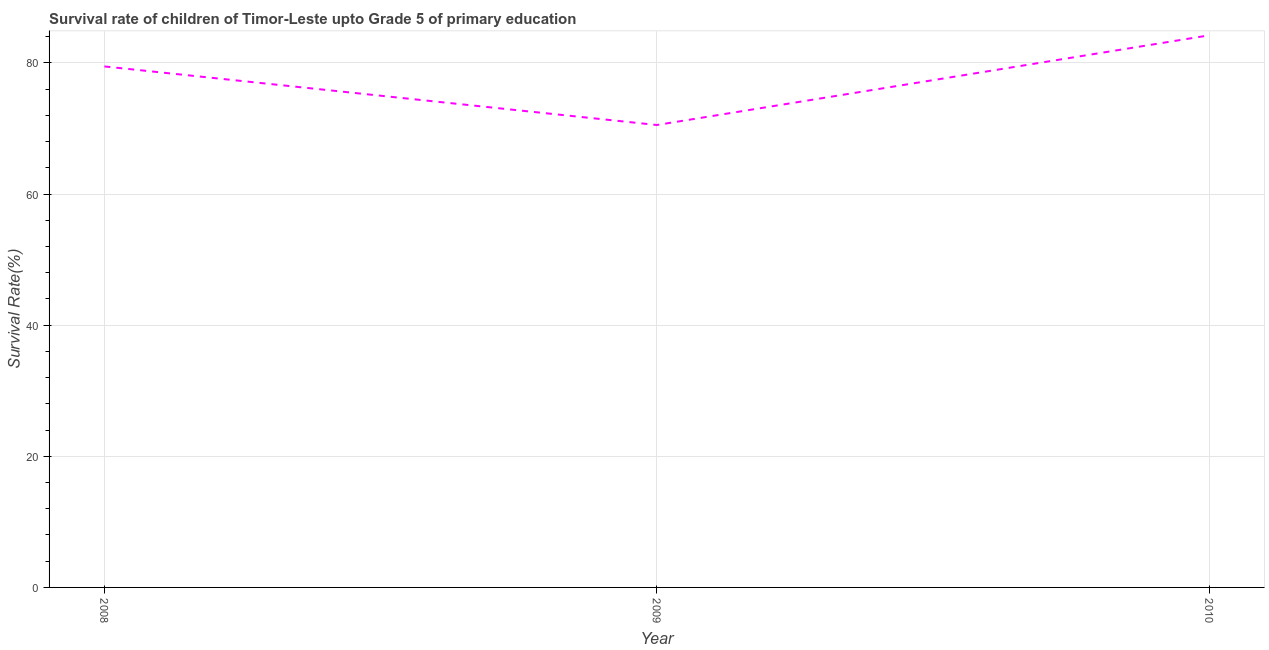What is the survival rate in 2009?
Your response must be concise. 70.53. Across all years, what is the maximum survival rate?
Offer a terse response. 84.2. Across all years, what is the minimum survival rate?
Provide a short and direct response. 70.53. What is the sum of the survival rate?
Provide a succinct answer. 234.19. What is the difference between the survival rate in 2009 and 2010?
Your answer should be compact. -13.68. What is the average survival rate per year?
Keep it short and to the point. 78.06. What is the median survival rate?
Ensure brevity in your answer.  79.46. What is the ratio of the survival rate in 2008 to that in 2009?
Provide a succinct answer. 1.13. Is the difference between the survival rate in 2008 and 2010 greater than the difference between any two years?
Make the answer very short. No. What is the difference between the highest and the second highest survival rate?
Provide a short and direct response. 4.75. What is the difference between the highest and the lowest survival rate?
Your answer should be very brief. 13.68. How many lines are there?
Your response must be concise. 1. What is the difference between two consecutive major ticks on the Y-axis?
Provide a short and direct response. 20. Does the graph contain any zero values?
Give a very brief answer. No. Does the graph contain grids?
Give a very brief answer. Yes. What is the title of the graph?
Your answer should be compact. Survival rate of children of Timor-Leste upto Grade 5 of primary education. What is the label or title of the Y-axis?
Your answer should be very brief. Survival Rate(%). What is the Survival Rate(%) in 2008?
Your response must be concise. 79.46. What is the Survival Rate(%) of 2009?
Your answer should be compact. 70.53. What is the Survival Rate(%) of 2010?
Give a very brief answer. 84.2. What is the difference between the Survival Rate(%) in 2008 and 2009?
Your response must be concise. 8.93. What is the difference between the Survival Rate(%) in 2008 and 2010?
Offer a terse response. -4.75. What is the difference between the Survival Rate(%) in 2009 and 2010?
Provide a short and direct response. -13.68. What is the ratio of the Survival Rate(%) in 2008 to that in 2009?
Your answer should be very brief. 1.13. What is the ratio of the Survival Rate(%) in 2008 to that in 2010?
Your response must be concise. 0.94. What is the ratio of the Survival Rate(%) in 2009 to that in 2010?
Your response must be concise. 0.84. 